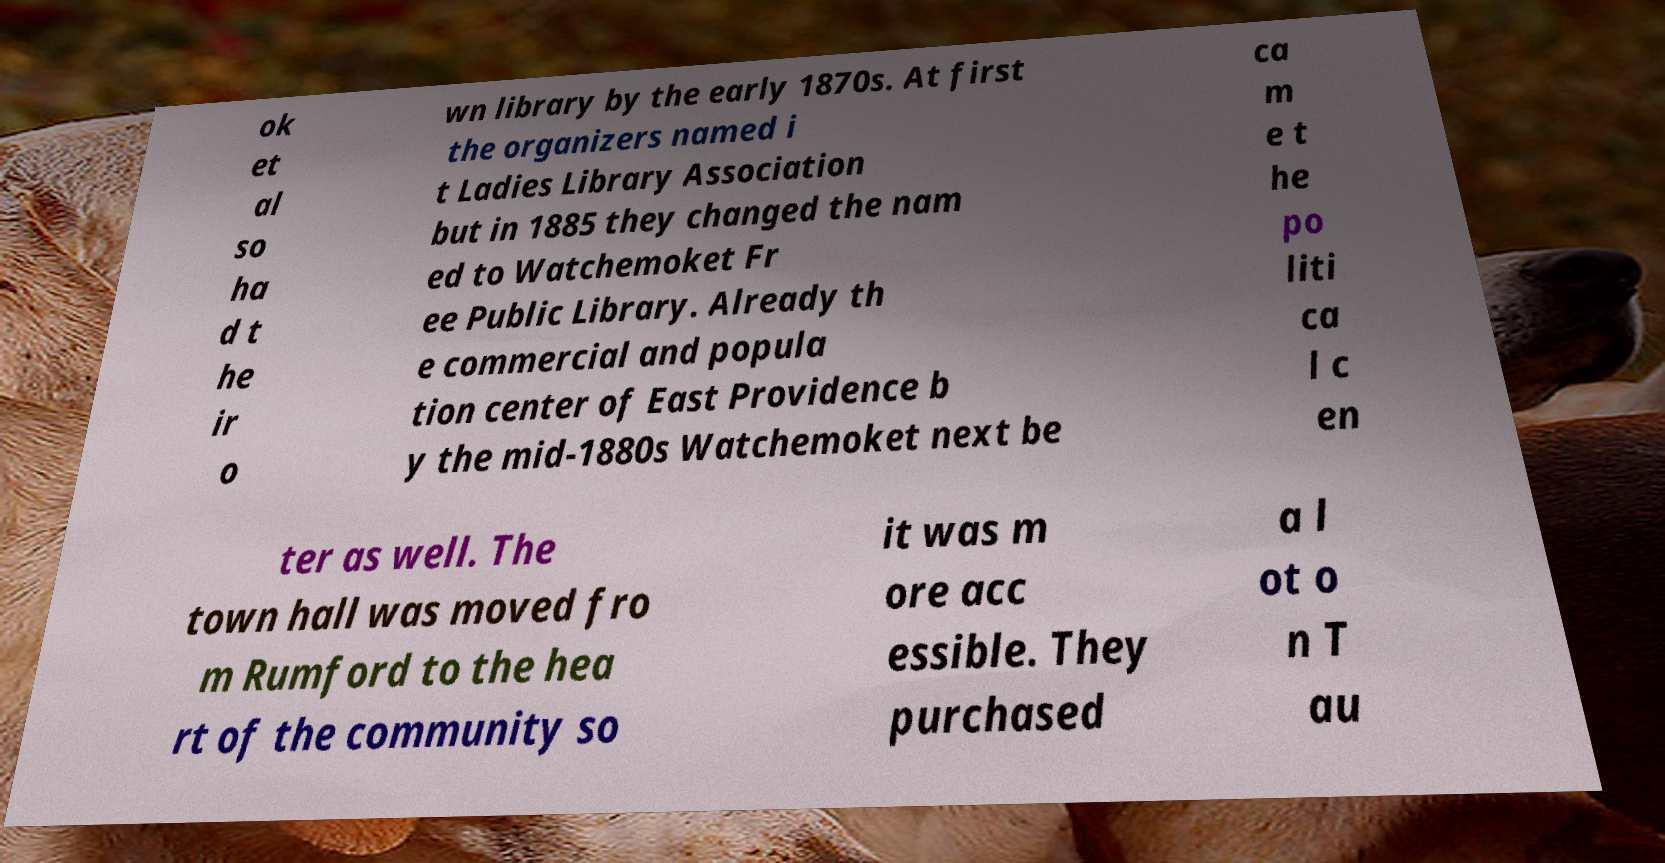Could you extract and type out the text from this image? ok et al so ha d t he ir o wn library by the early 1870s. At first the organizers named i t Ladies Library Association but in 1885 they changed the nam ed to Watchemoket Fr ee Public Library. Already th e commercial and popula tion center of East Providence b y the mid-1880s Watchemoket next be ca m e t he po liti ca l c en ter as well. The town hall was moved fro m Rumford to the hea rt of the community so it was m ore acc essible. They purchased a l ot o n T au 